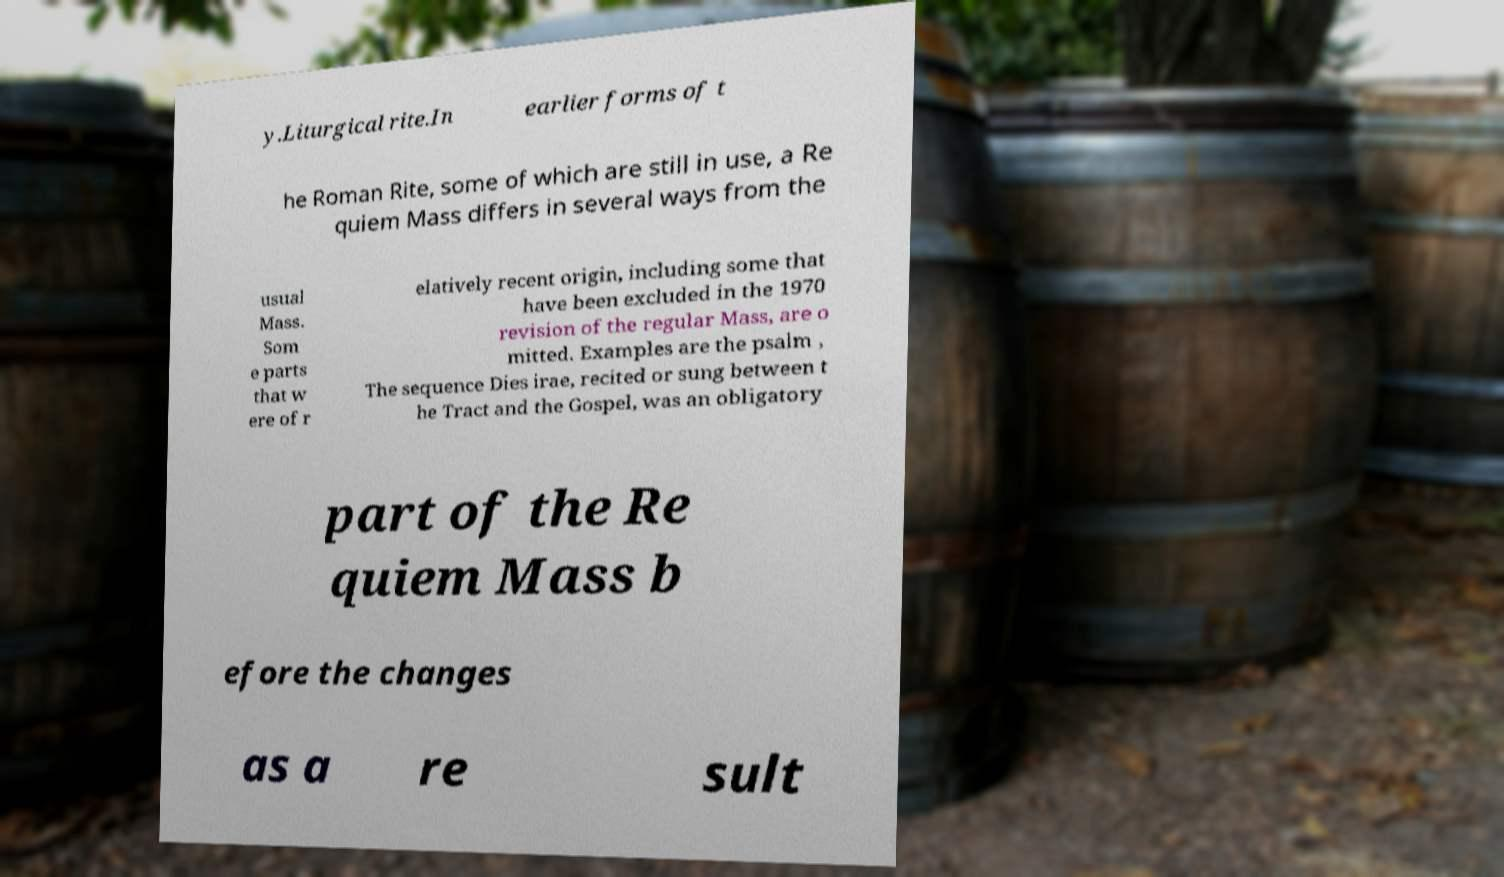Can you read and provide the text displayed in the image?This photo seems to have some interesting text. Can you extract and type it out for me? y.Liturgical rite.In earlier forms of t he Roman Rite, some of which are still in use, a Re quiem Mass differs in several ways from the usual Mass. Som e parts that w ere of r elatively recent origin, including some that have been excluded in the 1970 revision of the regular Mass, are o mitted. Examples are the psalm , The sequence Dies irae, recited or sung between t he Tract and the Gospel, was an obligatory part of the Re quiem Mass b efore the changes as a re sult 